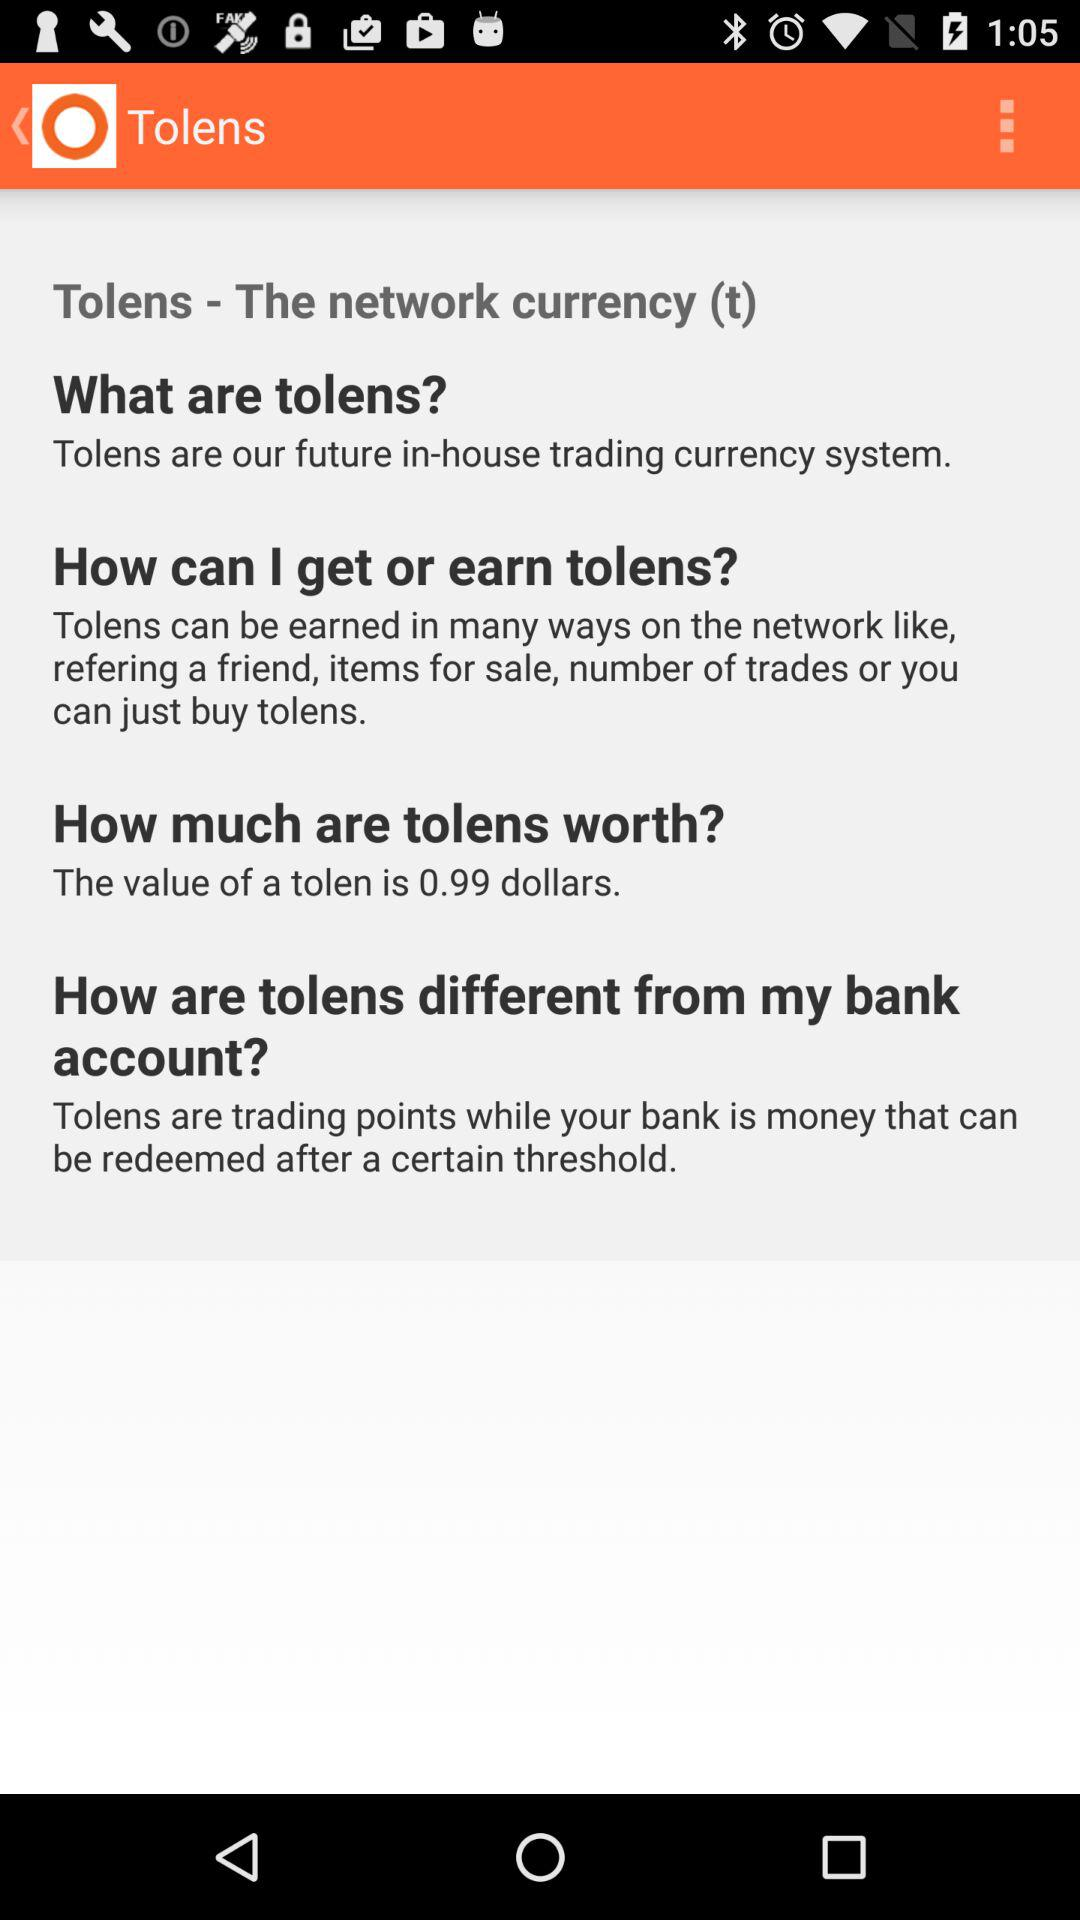How many dollars is the value of 1 tolen?
Answer the question using a single word or phrase. 0.99 